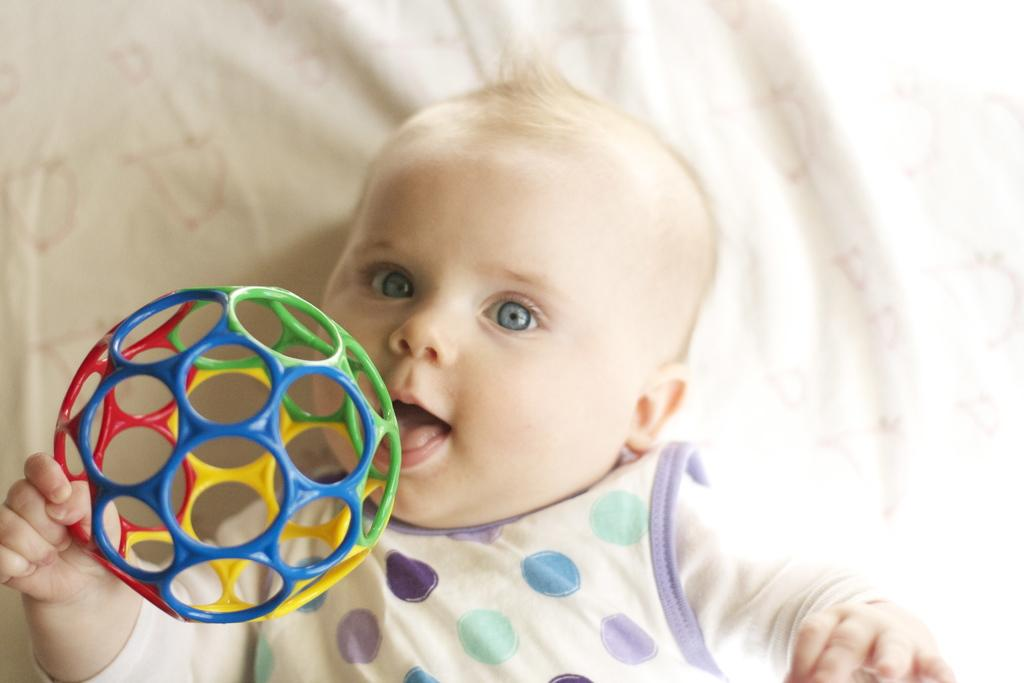What is the main subject of the image? The main subject of the image is a baby. What is the baby lying on in the image? The baby is lying on a cloth. What is the baby holding in their hand? The baby is holding a toy with their hand. What type of pet can be seen accompanying the baby in the image? There is no pet present in the image; it only features a baby lying on a cloth and holding a toy. 